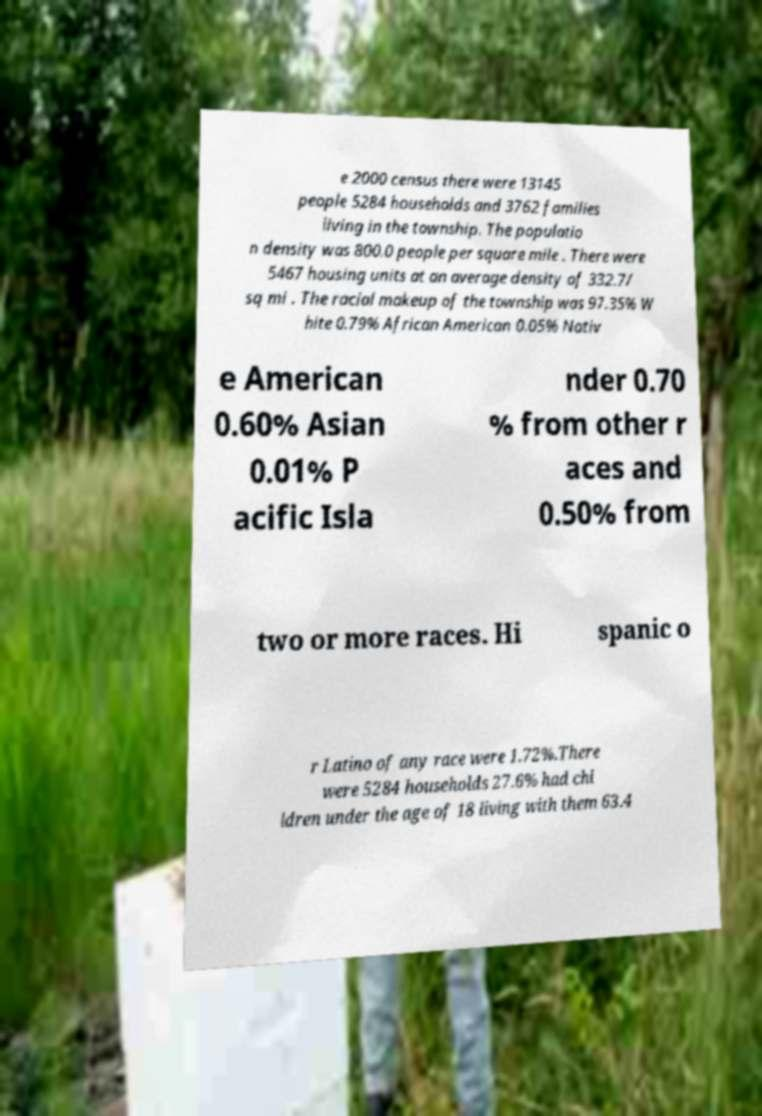There's text embedded in this image that I need extracted. Can you transcribe it verbatim? e 2000 census there were 13145 people 5284 households and 3762 families living in the township. The populatio n density was 800.0 people per square mile . There were 5467 housing units at an average density of 332.7/ sq mi . The racial makeup of the township was 97.35% W hite 0.79% African American 0.05% Nativ e American 0.60% Asian 0.01% P acific Isla nder 0.70 % from other r aces and 0.50% from two or more races. Hi spanic o r Latino of any race were 1.72%.There were 5284 households 27.6% had chi ldren under the age of 18 living with them 63.4 